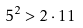<formula> <loc_0><loc_0><loc_500><loc_500>5 ^ { 2 } > 2 \cdot 1 1</formula> 